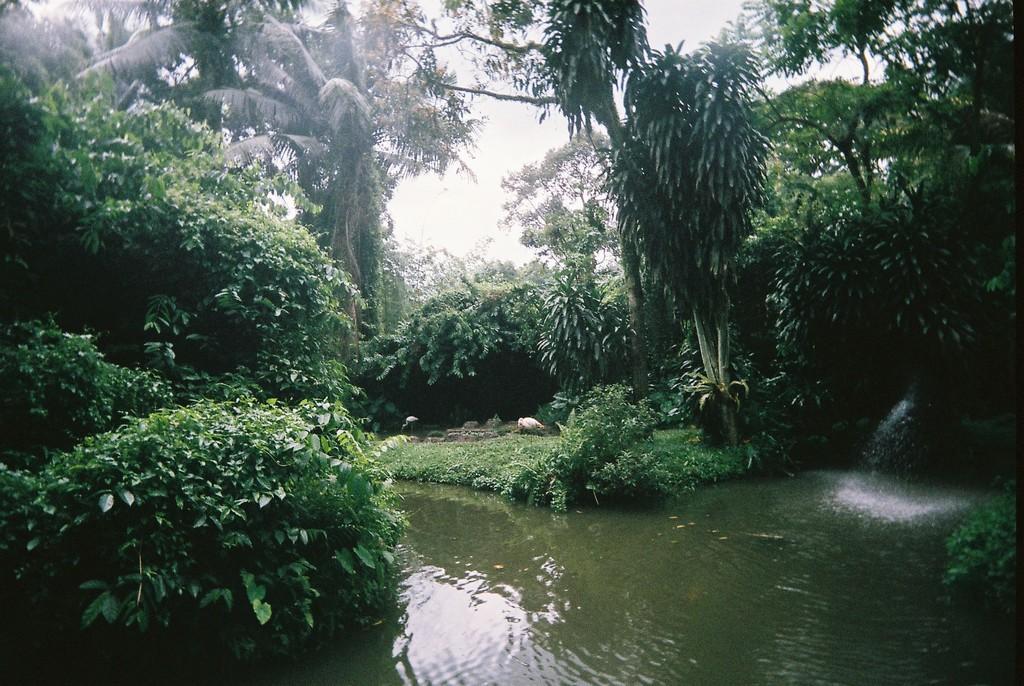Describe this image in one or two sentences. In this image, these are the trees with branches and leaves. I can see the bushes. This looks like a pond with the water flowing. These look like the birds. This is the sky. 